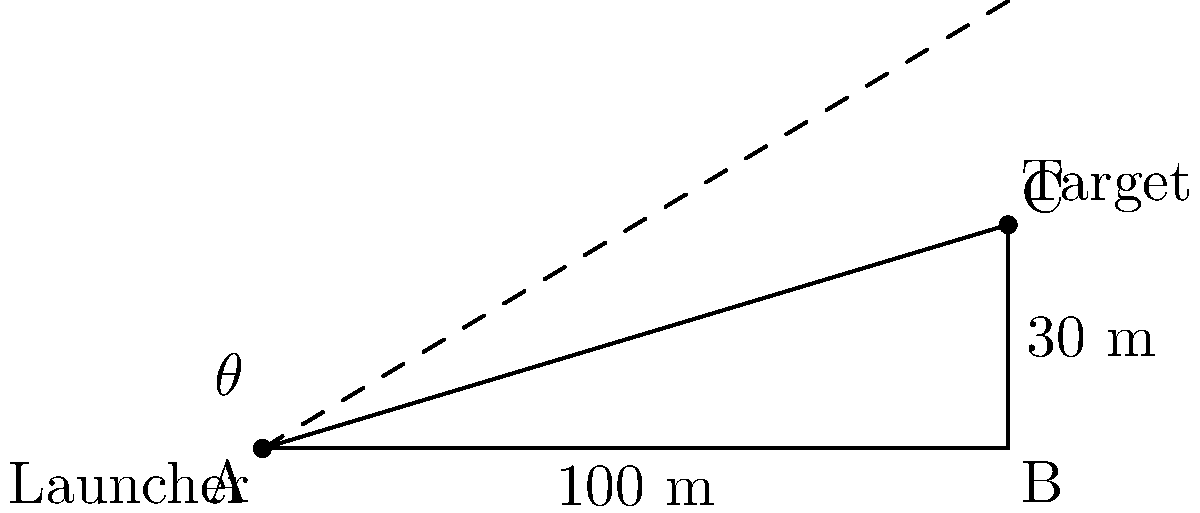A military exercise requires launching a projectile over a wall. The launcher is positioned 100 meters away from the base of the wall, which is 30 meters tall. What is the minimum angle of elevation (θ) needed for the projectile to clear the top of the wall, assuming it's launched from ground level? Round your answer to the nearest degree. To solve this problem, we'll use trigonometry, specifically the tangent function. Here's the step-by-step solution:

1) First, we need to identify the right triangle formed by the launcher, the top of the wall, and the ground.

2) The adjacent side of this triangle is the horizontal distance from the launcher to the wall, which is 100 meters.

3) The opposite side is the height of the wall, which is 30 meters.

4) We're looking for the angle θ, which is the angle of elevation.

5) In a right triangle, tangent of an angle is the ratio of the opposite side to the adjacent side:

   $$\tan(\theta) = \frac{\text{opposite}}{\text{adjacent}} = \frac{\text{height of wall}}{\text{distance to wall}}$$

6) Plugging in our values:

   $$\tan(\theta) = \frac{30}{100} = 0.3$$

7) To find θ, we need to use the inverse tangent (arctan or tan^(-1)):

   $$\theta = \tan^{-1}(0.3)$$

8) Using a calculator or trigonometric tables:

   $$\theta \approx 16.70^\circ$$

9) Rounding to the nearest degree:

   $$\theta \approx 17^\circ$$

Therefore, the minimum angle of elevation needed is approximately 17 degrees.
Answer: 17° 